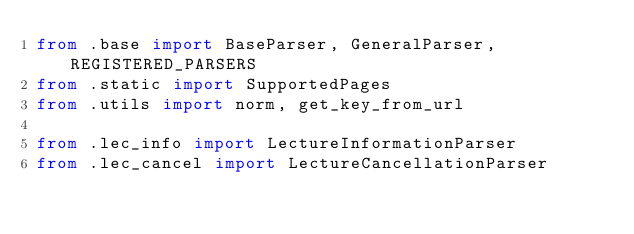Convert code to text. <code><loc_0><loc_0><loc_500><loc_500><_Python_>from .base import BaseParser, GeneralParser, REGISTERED_PARSERS
from .static import SupportedPages
from .utils import norm, get_key_from_url

from .lec_info import LectureInformationParser
from .lec_cancel import LectureCancellationParser</code> 